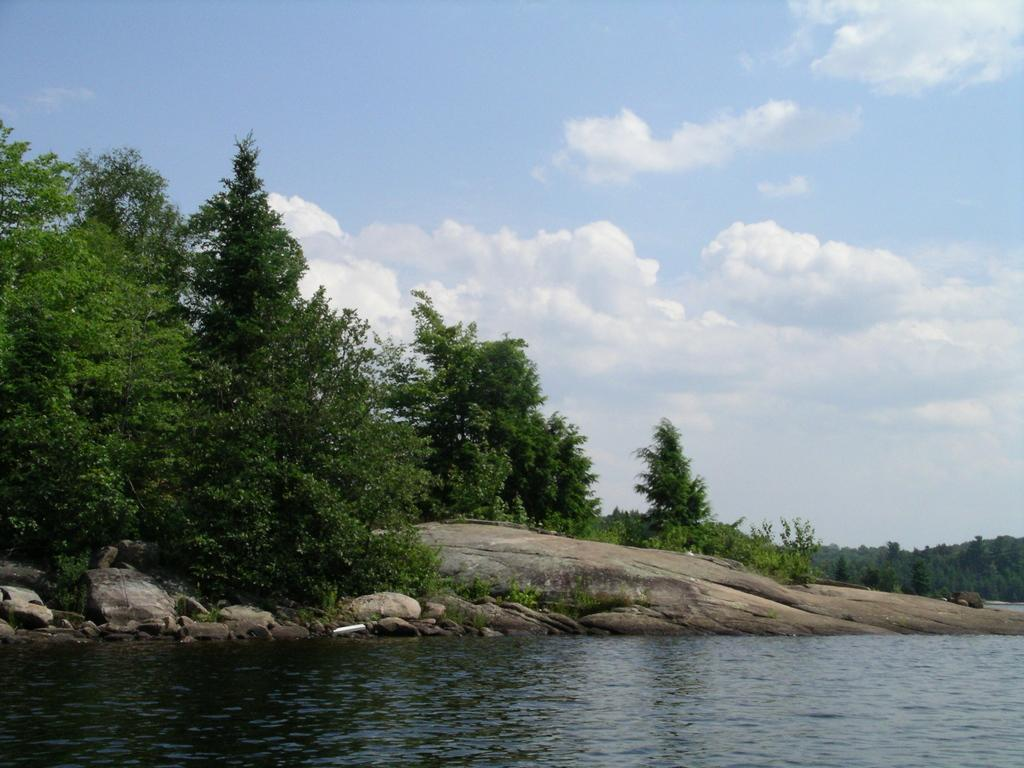What type of natural elements can be seen in the image? There are trees and rocks visible in the image. What is present at the bottom of the image? There is water visible at the bottom of the image. What can be seen in the sky at the top of the image? There are clouds in the sky at the top of the image. What is the size of the apple in the image? There is no apple present in the image. What is the value of the rocks in the image? The value of the rocks cannot be determined from the image, as they are not being sold or traded. 